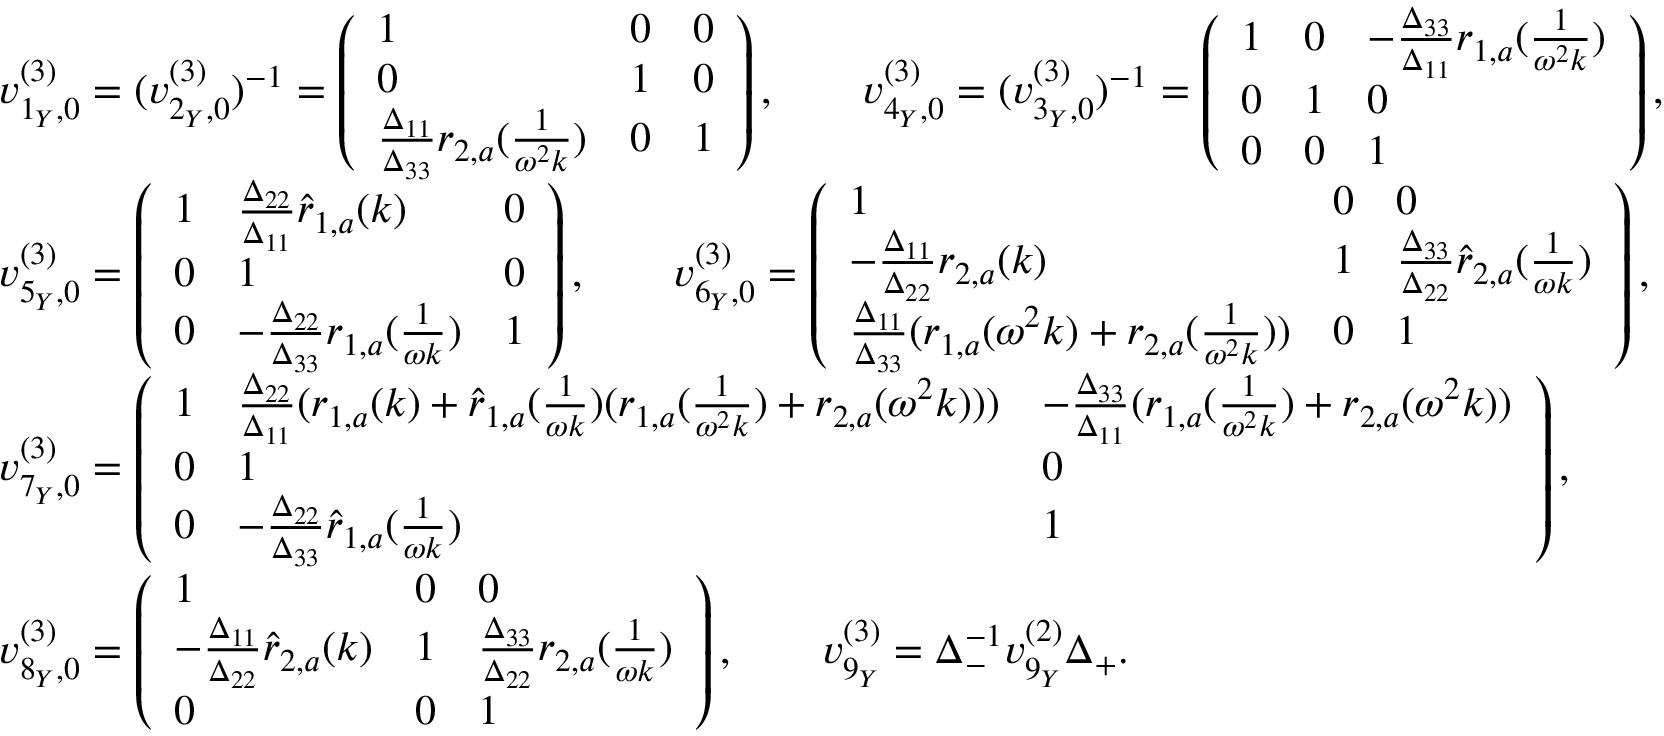<formula> <loc_0><loc_0><loc_500><loc_500>\begin{array} { r l } & { v _ { 1 _ { Y } , 0 } ^ { ( 3 ) } = ( v _ { 2 _ { Y } , 0 } ^ { ( 3 ) } ) ^ { - 1 } = \left ( \begin{array} { l l l } { 1 } & { 0 } & { 0 } \\ { 0 } & { 1 } & { 0 } \\ { \frac { \Delta _ { 1 1 } } { \Delta _ { 3 3 } } r _ { 2 , a } ( \frac { 1 } { \omega ^ { 2 } k } ) } & { 0 } & { 1 } \end{array} \right ) , \quad v _ { 4 _ { Y } , 0 } ^ { ( 3 ) } = ( v _ { 3 _ { Y } , 0 } ^ { ( 3 ) } ) ^ { - 1 } = \left ( \begin{array} { l l l } { 1 } & { 0 } & { - \frac { \Delta _ { 3 3 } } { \Delta _ { 1 1 } } r _ { 1 , a } ( \frac { 1 } { \omega ^ { 2 } k } ) } \\ { 0 } & { 1 } & { 0 } \\ { 0 } & { 0 } & { 1 } \end{array} \right ) , } \\ & { v _ { 5 _ { Y } , 0 } ^ { ( 3 ) } = \left ( \begin{array} { l l l } { 1 } & { \frac { \Delta _ { 2 2 } } { \Delta _ { 1 1 } } \hat { r } _ { 1 , a } ( k ) } & { 0 } \\ { 0 } & { 1 } & { 0 } \\ { 0 } & { - \frac { \Delta _ { 2 2 } } { \Delta _ { 3 3 } } r _ { 1 , a } ( \frac { 1 } { \omega k } ) } & { 1 } \end{array} \right ) , \quad v _ { 6 _ { Y } , 0 } ^ { ( 3 ) } = \left ( \begin{array} { l l l } { 1 } & { 0 } & { 0 } \\ { - \frac { \Delta _ { 1 1 } } { \Delta _ { 2 2 } } r _ { 2 , a } ( k ) } & { 1 } & { \frac { \Delta _ { 3 3 } } { \Delta _ { 2 2 } } \hat { r } _ { 2 , a } ( \frac { 1 } { \omega k } ) } \\ { \frac { \Delta _ { 1 1 } } { \Delta _ { 3 3 } } ( r _ { 1 , a } ( \omega ^ { 2 } k ) + r _ { 2 , a } ( \frac { 1 } { \omega ^ { 2 } k } ) ) } & { 0 } & { 1 } \end{array} \right ) , } \\ & { v _ { 7 _ { Y } , 0 } ^ { ( 3 ) } = \left ( \begin{array} { l l l } { 1 } & { \frac { \Delta _ { 2 2 } } { \Delta _ { 1 1 } } ( r _ { 1 , a } ( k ) + \hat { r } _ { 1 , a } ( \frac { 1 } { \omega k } ) ( r _ { 1 , a } ( \frac { 1 } { \omega ^ { 2 } k } ) + r _ { 2 , a } ( \omega ^ { 2 } k ) ) ) } & { - \frac { \Delta _ { 3 3 } } { \Delta _ { 1 1 } } ( r _ { 1 , a } ( \frac { 1 } { \omega ^ { 2 } k } ) + r _ { 2 , a } ( \omega ^ { 2 } k ) ) } \\ { 0 } & { 1 } & { 0 } \\ { 0 } & { - \frac { \Delta _ { 2 2 } } { \Delta _ { 3 3 } } \hat { r } _ { 1 , a } ( \frac { 1 } { \omega k } ) } & { 1 } \end{array} \right ) , } \\ & { v _ { 8 _ { Y } , 0 } ^ { ( 3 ) } = \left ( \begin{array} { l l l } { 1 } & { 0 } & { 0 } \\ { - \frac { \Delta _ { 1 1 } } { \Delta _ { 2 2 } } \hat { r } _ { 2 , a } ( k ) } & { 1 } & { \frac { \Delta _ { 3 3 } } { \Delta _ { 2 2 } } r _ { 2 , a } ( \frac { 1 } { \omega k } ) } \\ { 0 } & { 0 } & { 1 } \end{array} \right ) , \quad v _ { 9 _ { Y } } ^ { ( 3 ) } = \Delta _ { - } ^ { - 1 } v _ { 9 _ { Y } } ^ { ( 2 ) } \Delta _ { + } . } \end{array}</formula> 